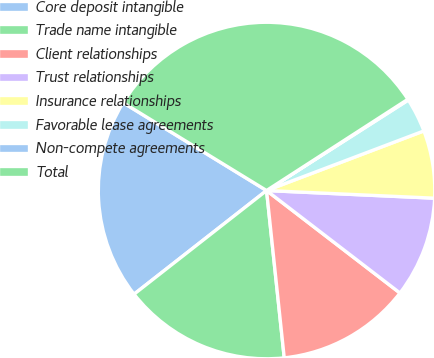Convert chart to OTSL. <chart><loc_0><loc_0><loc_500><loc_500><pie_chart><fcel>Core deposit intangible<fcel>Trade name intangible<fcel>Client relationships<fcel>Trust relationships<fcel>Insurance relationships<fcel>Favorable lease agreements<fcel>Non-compete agreements<fcel>Total<nl><fcel>19.31%<fcel>16.11%<fcel>12.9%<fcel>9.7%<fcel>6.49%<fcel>3.28%<fcel>0.08%<fcel>32.13%<nl></chart> 